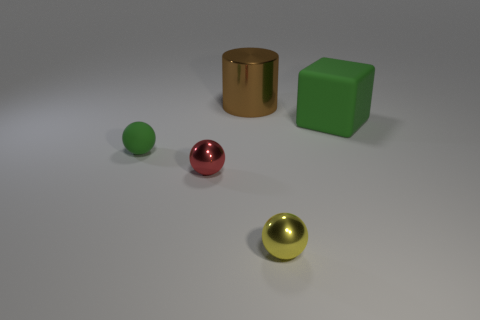What could be inferred about the sizes of the objects relative to each other? From the perspective in the image, it can be inferred that the green cube is larger than the round objects but smaller than the tall cylinder. The round objects vary in size as well, with the red sphere appearing slightly larger than the green and golden spheres. 